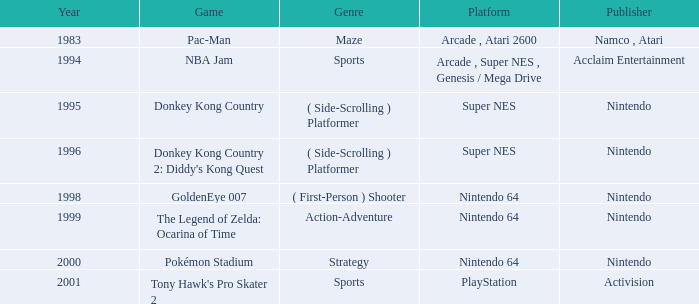I'm looking to parse the entire table for insights. Could you assist me with that? {'header': ['Year', 'Game', 'Genre', 'Platform', 'Publisher'], 'rows': [['1983', 'Pac-Man', 'Maze', 'Arcade , Atari 2600', 'Namco , Atari'], ['1994', 'NBA Jam', 'Sports', 'Arcade , Super NES , Genesis / Mega Drive', 'Acclaim Entertainment'], ['1995', 'Donkey Kong Country', '( Side-Scrolling ) Platformer', 'Super NES', 'Nintendo'], ['1996', "Donkey Kong Country 2: Diddy's Kong Quest", '( Side-Scrolling ) Platformer', 'Super NES', 'Nintendo'], ['1998', 'GoldenEye 007', '( First-Person ) Shooter', 'Nintendo 64', 'Nintendo'], ['1999', 'The Legend of Zelda: Ocarina of Time', 'Action-Adventure', 'Nintendo 64', 'Nintendo'], ['2000', 'Pokémon Stadium', 'Strategy', 'Nintendo 64', 'Nintendo'], ['2001', "Tony Hawk's Pro Skater 2", 'Sports', 'PlayStation', 'Activision']]} Which Genre has a Game of donkey kong country? ( Side-Scrolling ) Platformer. 